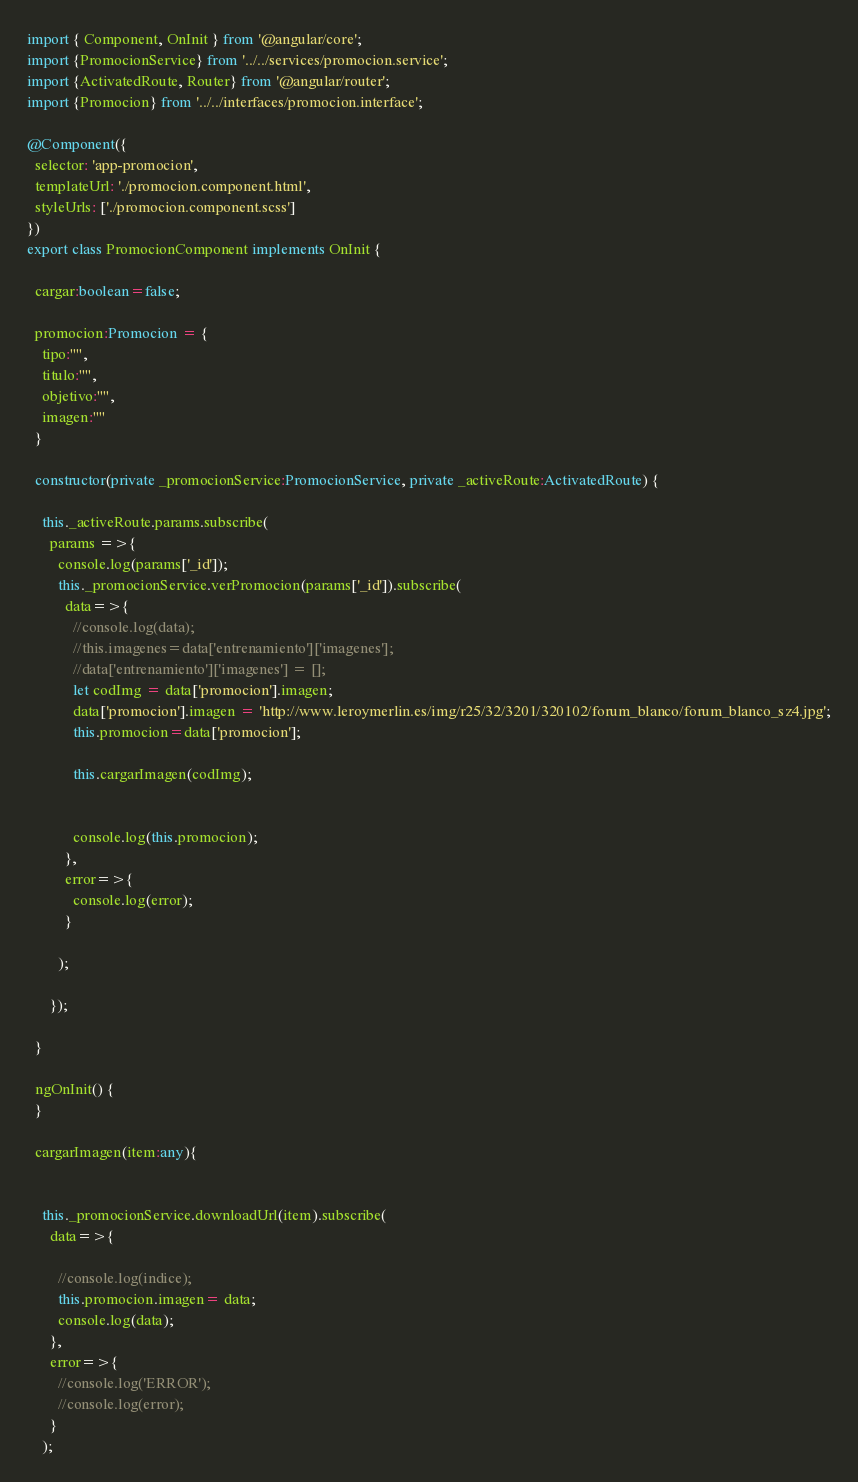Convert code to text. <code><loc_0><loc_0><loc_500><loc_500><_TypeScript_>import { Component, OnInit } from '@angular/core';
import {PromocionService} from '../../services/promocion.service';
import {ActivatedRoute, Router} from '@angular/router';
import {Promocion} from '../../interfaces/promocion.interface';

@Component({
  selector: 'app-promocion',
  templateUrl: './promocion.component.html',
  styleUrls: ['./promocion.component.scss']
})
export class PromocionComponent implements OnInit {

  cargar:boolean=false;

  promocion:Promocion = {
    tipo:"",
    titulo:"",
    objetivo:"",
    imagen:""
  }

  constructor(private _promocionService:PromocionService, private _activeRoute:ActivatedRoute) { 

    this._activeRoute.params.subscribe(
      params =>{
        console.log(params['_id']);
        this._promocionService.verPromocion(params['_id']).subscribe(
          data=>{
            //console.log(data);
            //this.imagenes=data['entrenamiento']['imagenes'];
            //data['entrenamiento']['imagenes'] = [];
            let codImg = data['promocion'].imagen; 
            data['promocion'].imagen = 'http://www.leroymerlin.es/img/r25/32/3201/320102/forum_blanco/forum_blanco_sz4.jpg';
            this.promocion=data['promocion'];
            
            this.cargarImagen(codImg);


            console.log(this.promocion);
          },
          error=>{
            console.log(error);
          }

        );
        
      });

  }

  ngOnInit() {
  }

  cargarImagen(item:any){

  
    this._promocionService.downloadUrl(item).subscribe(
      data=>{
        
        //console.log(indice);
        this.promocion.imagen= data;
        console.log(data);
      },
      error=>{
        //console.log('ERROR');
        //console.log(error);
      }
    );
</code> 